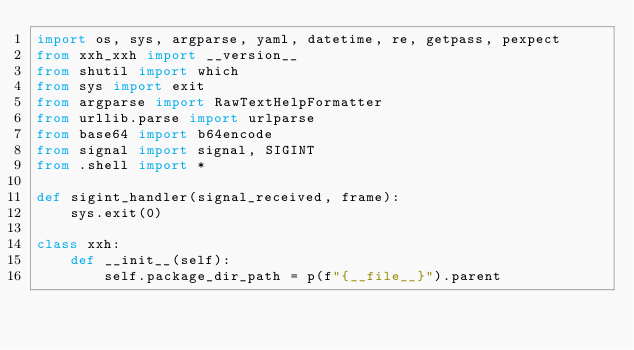<code> <loc_0><loc_0><loc_500><loc_500><_Python_>import os, sys, argparse, yaml, datetime, re, getpass, pexpect
from xxh_xxh import __version__
from shutil import which
from sys import exit
from argparse import RawTextHelpFormatter
from urllib.parse import urlparse
from base64 import b64encode
from signal import signal, SIGINT
from .shell import *

def sigint_handler(signal_received, frame):
    sys.exit(0)

class xxh:
    def __init__(self):
        self.package_dir_path = p(f"{__file__}").parent</code> 